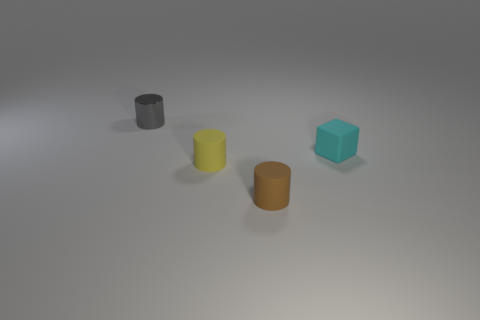Add 2 brown cylinders. How many objects exist? 6 Subtract all blocks. How many objects are left? 3 Add 1 tiny green metal things. How many tiny green metal things exist? 1 Subtract 1 brown cylinders. How many objects are left? 3 Subtract all small yellow cylinders. Subtract all large cyan matte cubes. How many objects are left? 3 Add 4 metal things. How many metal things are left? 5 